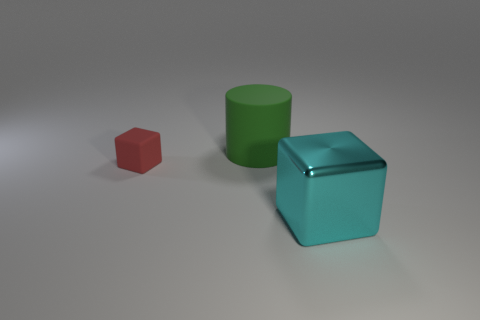There is another tiny object that is the same shape as the metal object; what is its material?
Offer a terse response. Rubber. Are there any other things that are made of the same material as the large green thing?
Give a very brief answer. Yes. What number of other objects are the same shape as the green object?
Ensure brevity in your answer.  0. What number of big green cylinders are behind the cube that is to the left of the large object in front of the big green cylinder?
Provide a short and direct response. 1. How many big cyan things are the same shape as the small red rubber thing?
Your response must be concise. 1. What is the shape of the large thing that is behind the cube in front of the cube behind the big cyan shiny object?
Keep it short and to the point. Cylinder. There is a red rubber object; is its size the same as the cube on the right side of the big green rubber cylinder?
Offer a terse response. No. Are there any metal blocks that have the same size as the green matte cylinder?
Make the answer very short. Yes. How many other things are the same material as the cyan thing?
Offer a terse response. 0. There is a thing that is both to the right of the tiny red block and in front of the green rubber object; what color is it?
Make the answer very short. Cyan. 